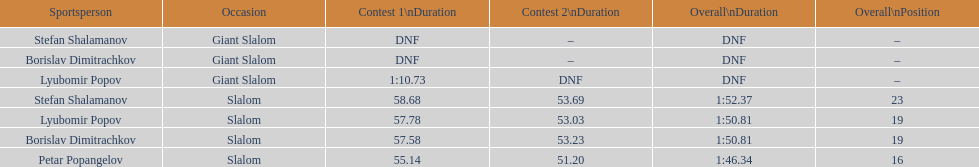Parse the table in full. {'header': ['Sportsperson', 'Occasion', 'Contest 1\\nDuration', 'Contest 2\\nDuration', 'Overall\\nDuration', 'Overall\\nPosition'], 'rows': [['Stefan Shalamanov', 'Giant Slalom', 'DNF', '–', 'DNF', '–'], ['Borislav Dimitrachkov', 'Giant Slalom', 'DNF', '–', 'DNF', '–'], ['Lyubomir Popov', 'Giant Slalom', '1:10.73', 'DNF', 'DNF', '–'], ['Stefan Shalamanov', 'Slalom', '58.68', '53.69', '1:52.37', '23'], ['Lyubomir Popov', 'Slalom', '57.78', '53.03', '1:50.81', '19'], ['Borislav Dimitrachkov', 'Slalom', '57.58', '53.23', '1:50.81', '19'], ['Petar Popangelov', 'Slalom', '55.14', '51.20', '1:46.34', '16']]} Which athletes had consecutive times under 58 for both races? Lyubomir Popov, Borislav Dimitrachkov, Petar Popangelov. 